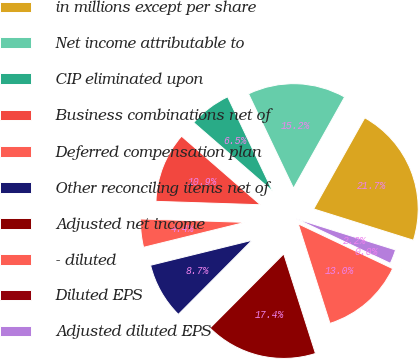Convert chart. <chart><loc_0><loc_0><loc_500><loc_500><pie_chart><fcel>in millions except per share<fcel>Net income attributable to<fcel>CIP eliminated upon<fcel>Business combinations net of<fcel>Deferred compensation plan<fcel>Other reconciling items net of<fcel>Adjusted net income<fcel>- diluted<fcel>Diluted EPS<fcel>Adjusted diluted EPS<nl><fcel>21.71%<fcel>15.21%<fcel>6.53%<fcel>10.87%<fcel>4.36%<fcel>8.7%<fcel>17.37%<fcel>13.04%<fcel>0.02%<fcel>2.19%<nl></chart> 